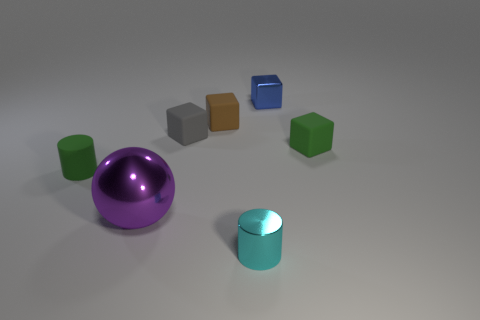Subtract all brown cubes. How many cubes are left? 3 Add 3 purple metal objects. How many objects exist? 10 Subtract all spheres. How many objects are left? 6 Subtract all green cylinders. How many cylinders are left? 1 Subtract 4 cubes. How many cubes are left? 0 Subtract all green cubes. Subtract all green cylinders. How many cubes are left? 3 Subtract all tiny green rubber cylinders. Subtract all blue cubes. How many objects are left? 5 Add 1 small blue shiny things. How many small blue shiny things are left? 2 Add 4 small objects. How many small objects exist? 10 Subtract 0 brown cylinders. How many objects are left? 7 